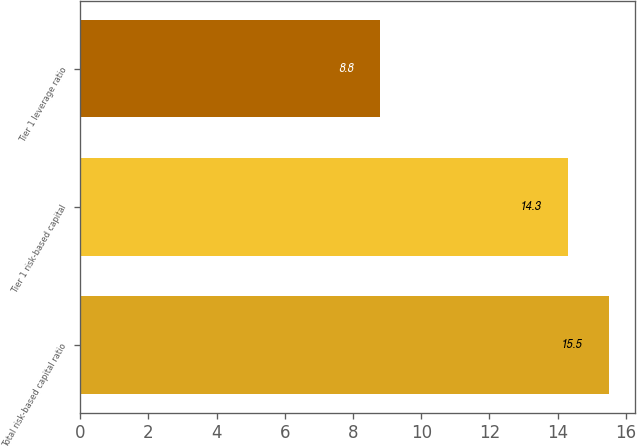Convert chart. <chart><loc_0><loc_0><loc_500><loc_500><bar_chart><fcel>Total risk-based capital ratio<fcel>Tier 1 risk-based capital<fcel>Tier 1 leverage ratio<nl><fcel>15.5<fcel>14.3<fcel>8.8<nl></chart> 